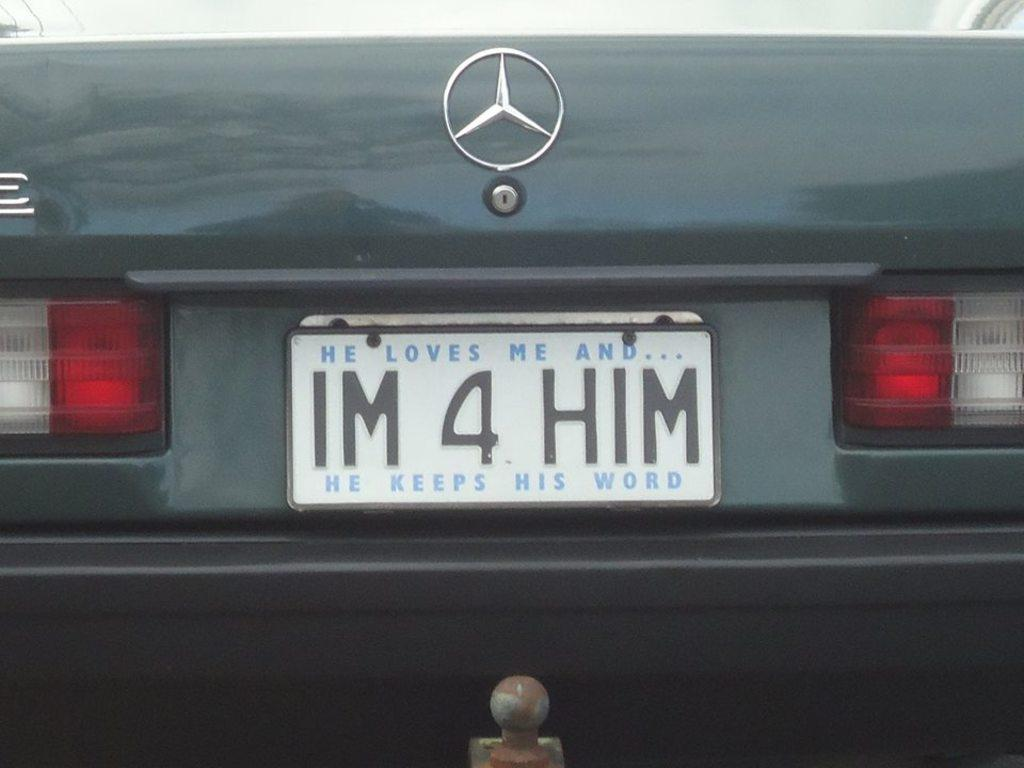<image>
Render a clear and concise summary of the photo. A license plate that says IM 4 HIM on the back of a car. 